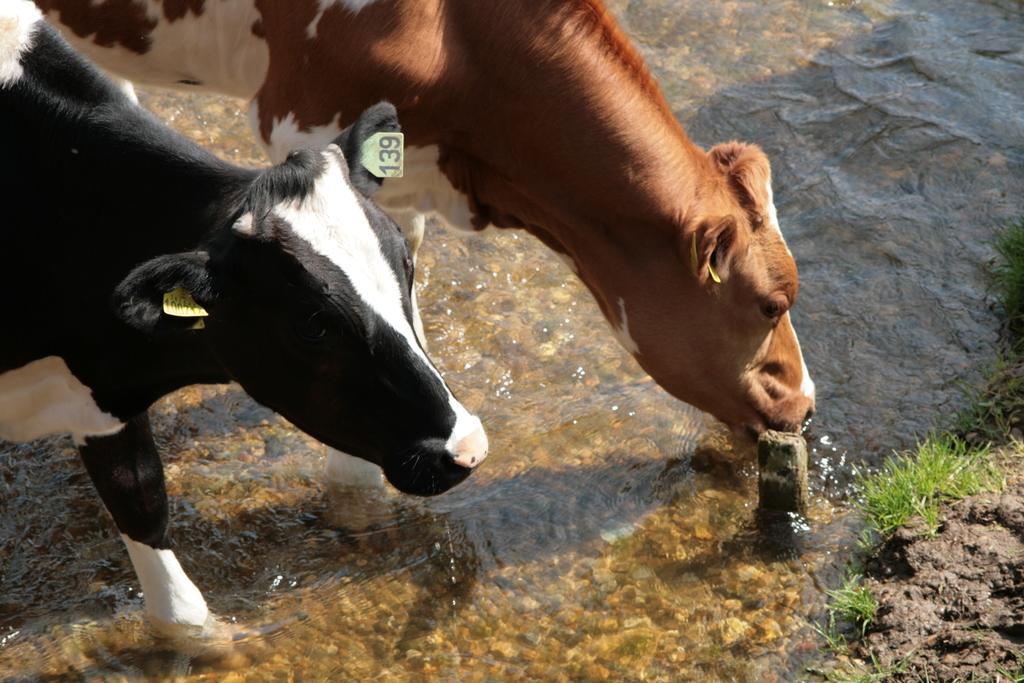How would you summarize this image in a sentence or two? As we can see in the image there is water, grass and different colors of cows. 